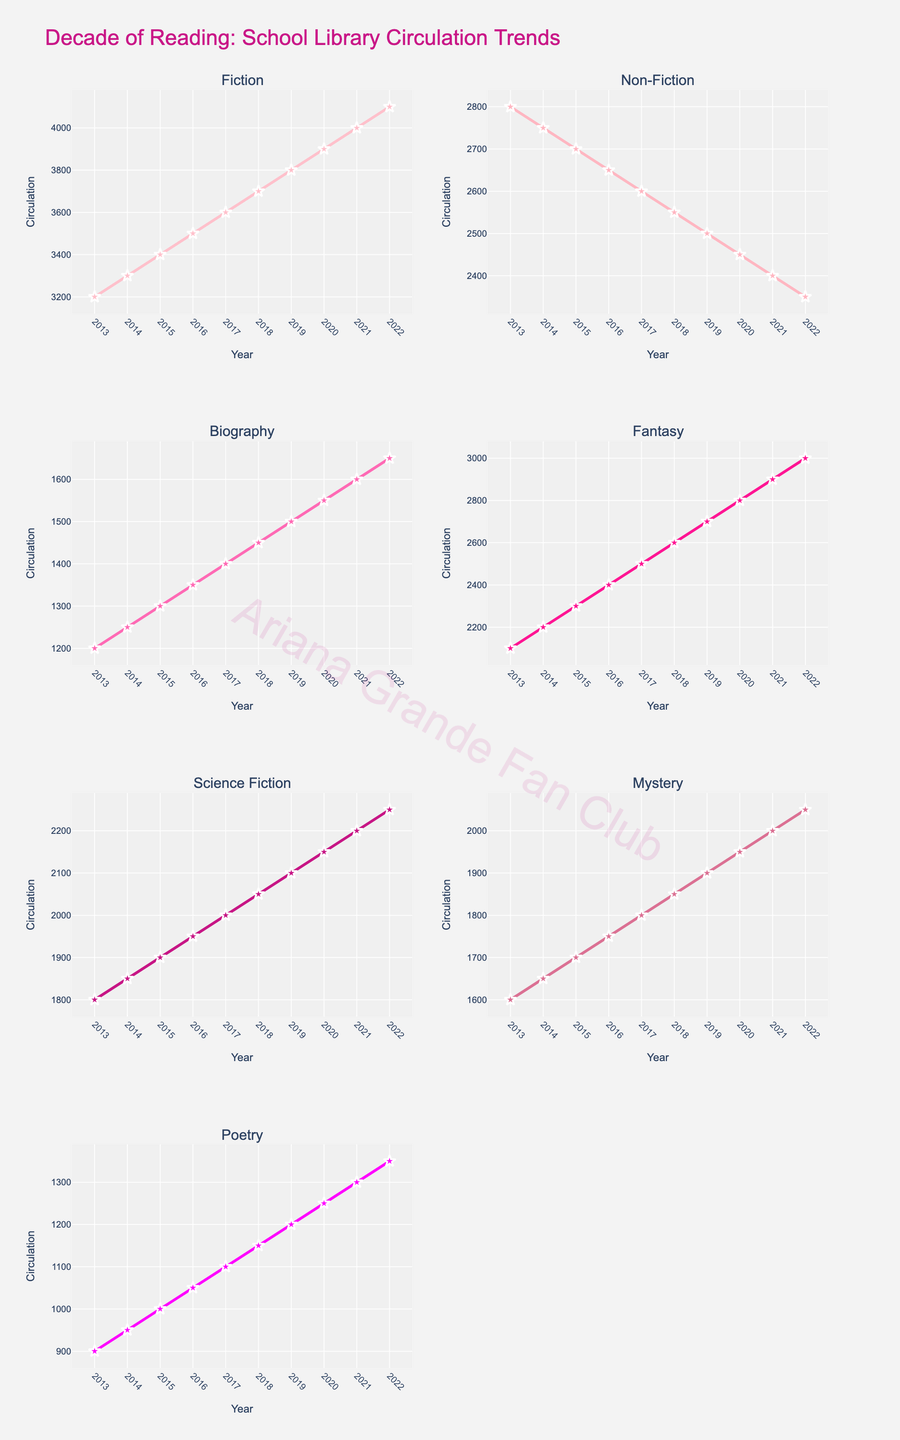Is there a genre where the circulation consistently increases every year? By examining the trends for each genre individually, we can see that the Fiction genre has a consistent year-over-year increase in circulation from 2013 to 2022.
Answer: Yes, Fiction How many times does the Poetry genre's circulation exceed 1000? From the plot, the Poetry genre's circulation exceeds 1000 from 2015 to 2022. Count the number of years during this period.
Answer: 8 times Which genre reached the highest circulation figure in 2022? Reviewing each subplot's value for 2022, Fiction has the highest circulation figure of 4100.
Answer: Fiction What is the average circulation of the Mystery genre over the decade? Sum the circulation values for the Mystery genre across all years and then divide by the number of years: (1600 + 1650 + 1700 + 1750 + 1800 + 1850 + 1900 + 1950 + 2000 + 2050) / 10 = 1825.
Answer: 1825 Which year did the Fantasy genre surpass the 2500 circulation mark? From the plot, the Fantasy genre surpassed the 2500 circulation mark in 2017.
Answer: 2017 Comparing the beginning and end of the decade, which genre had the smallest increase in circulation? Calculate the difference between 2022 and 2013 figures for each genre and compare. The smallest increase is in Non-Fiction (2350 - 2800 = -450).
Answer: Non-Fiction Do any genres exhibit a decreasing trend in circulation over time? Observing each genre's subplot, we see that only Non-Fiction decreases over the decade, from 2800 in 2013 to 2350 in 2022.
Answer: Yes, Non-Fiction For which genre did the circulation increase by exactly 100 each year? Checking each genre's annual increments, the Fiction genre increases by exactly 100 each year.
Answer: Fiction Which genre had its circulation double over the decade? Check if any genre’s 2022 figure is double that of 2013. Biography starts at 1200 in 2013 and ends at 1650 in 2022, not exactly double. None of the other genres show an exact doubling either.
Answer: None How did the circulation of the Science Fiction genre change from 2013 to 2020? Observe the Science Fiction subplot from 2013 to 2020. The circulation rose from 1800 in 2013 to 2150 in 2020.
Answer: Increased 